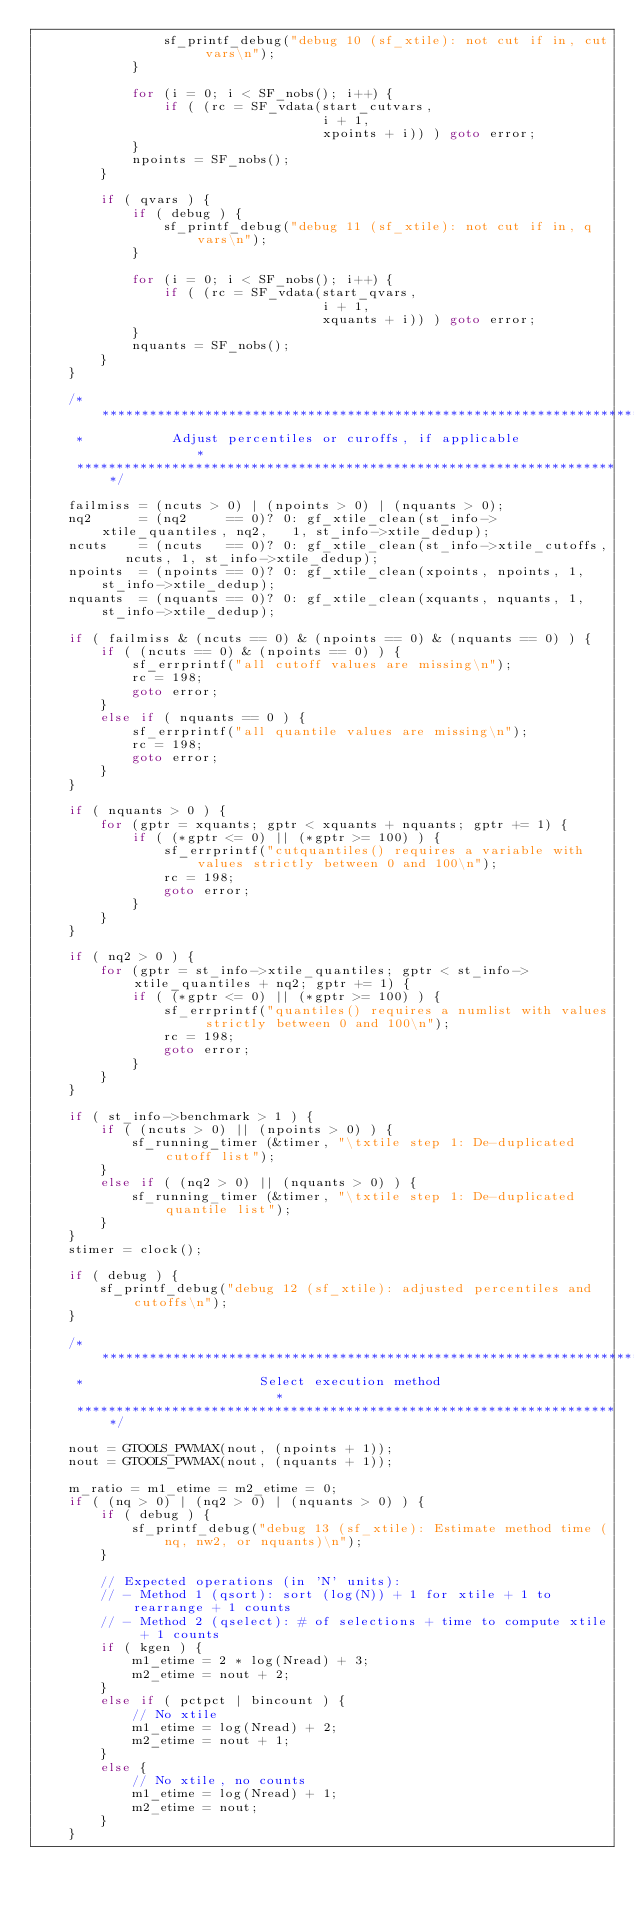<code> <loc_0><loc_0><loc_500><loc_500><_C_>                sf_printf_debug("debug 10 (sf_xtile): not cut if in, cut vars\n");
            }

            for (i = 0; i < SF_nobs(); i++) {
                if ( (rc = SF_vdata(start_cutvars,
                                    i + 1,
                                    xpoints + i)) ) goto error;
            }
            npoints = SF_nobs();
        }

        if ( qvars ) {
            if ( debug ) {
                sf_printf_debug("debug 11 (sf_xtile): not cut if in, q vars\n");
            }

            for (i = 0; i < SF_nobs(); i++) {
                if ( (rc = SF_vdata(start_qvars,
                                    i + 1,
                                    xquants + i)) ) goto error;
            }
            nquants = SF_nobs();
        }
    }

    /*********************************************************************
     *           Adjust percentiles or curoffs, if applicable            *
     *********************************************************************/

    failmiss = (ncuts > 0) | (npoints > 0) | (nquants > 0);
    nq2      = (nq2     == 0)? 0: gf_xtile_clean(st_info->xtile_quantiles, nq2,   1, st_info->xtile_dedup);
    ncuts    = (ncuts   == 0)? 0: gf_xtile_clean(st_info->xtile_cutoffs,   ncuts, 1, st_info->xtile_dedup);
    npoints  = (npoints == 0)? 0: gf_xtile_clean(xpoints, npoints, 1, st_info->xtile_dedup);
    nquants  = (nquants == 0)? 0: gf_xtile_clean(xquants, nquants, 1, st_info->xtile_dedup);

    if ( failmiss & (ncuts == 0) & (npoints == 0) & (nquants == 0) ) {
        if ( (ncuts == 0) & (npoints == 0) ) {
            sf_errprintf("all cutoff values are missing\n");
            rc = 198;
            goto error;
        }
        else if ( nquants == 0 ) {
            sf_errprintf("all quantile values are missing\n");
            rc = 198;
            goto error;
        }
    }

    if ( nquants > 0 ) {
        for (gptr = xquants; gptr < xquants + nquants; gptr += 1) {
            if ( (*gptr <= 0) || (*gptr >= 100) ) {
                sf_errprintf("cutquantiles() requires a variable with values strictly between 0 and 100\n");
                rc = 198;
                goto error;
            }
        }
    }

    if ( nq2 > 0 ) {
        for (gptr = st_info->xtile_quantiles; gptr < st_info->xtile_quantiles + nq2; gptr += 1) {
            if ( (*gptr <= 0) || (*gptr >= 100) ) {
                sf_errprintf("quantiles() requires a numlist with values strictly between 0 and 100\n");
                rc = 198;
                goto error;
            }
        }
    }

    if ( st_info->benchmark > 1 ) {
        if ( (ncuts > 0) || (npoints > 0) ) {
            sf_running_timer (&timer, "\txtile step 1: De-duplicated cutoff list");
        }
        else if ( (nq2 > 0) || (nquants > 0) ) {
            sf_running_timer (&timer, "\txtile step 1: De-duplicated quantile list");
        }
    }
    stimer = clock();

    if ( debug ) {
        sf_printf_debug("debug 12 (sf_xtile): adjusted percentiles and cutoffs\n");
    }

    /*********************************************************************
     *                      Select execution method                      *
     *********************************************************************/

    nout = GTOOLS_PWMAX(nout, (npoints + 1));
    nout = GTOOLS_PWMAX(nout, (nquants + 1));

    m_ratio = m1_etime = m2_etime = 0;
    if ( (nq > 0) | (nq2 > 0) | (nquants > 0) ) {
        if ( debug ) {
            sf_printf_debug("debug 13 (sf_xtile): Estimate method time (nq, nw2, or nquants)\n");
        }

        // Expected operations (in 'N' units):
        // - Method 1 (qsort): sort (log(N)) + 1 for xtile + 1 to rearrange + 1 counts
        // - Method 2 (qselect): # of selections + time to compute xtile + 1 counts
        if ( kgen ) {
            m1_etime = 2 * log(Nread) + 3;
            m2_etime = nout + 2;
        }
        else if ( pctpct | bincount ) {
            // No xtile
            m1_etime = log(Nread) + 2;
            m2_etime = nout + 1;
        }
        else {
            // No xtile, no counts
            m1_etime = log(Nread) + 1;
            m2_etime = nout;
        }
    }</code> 